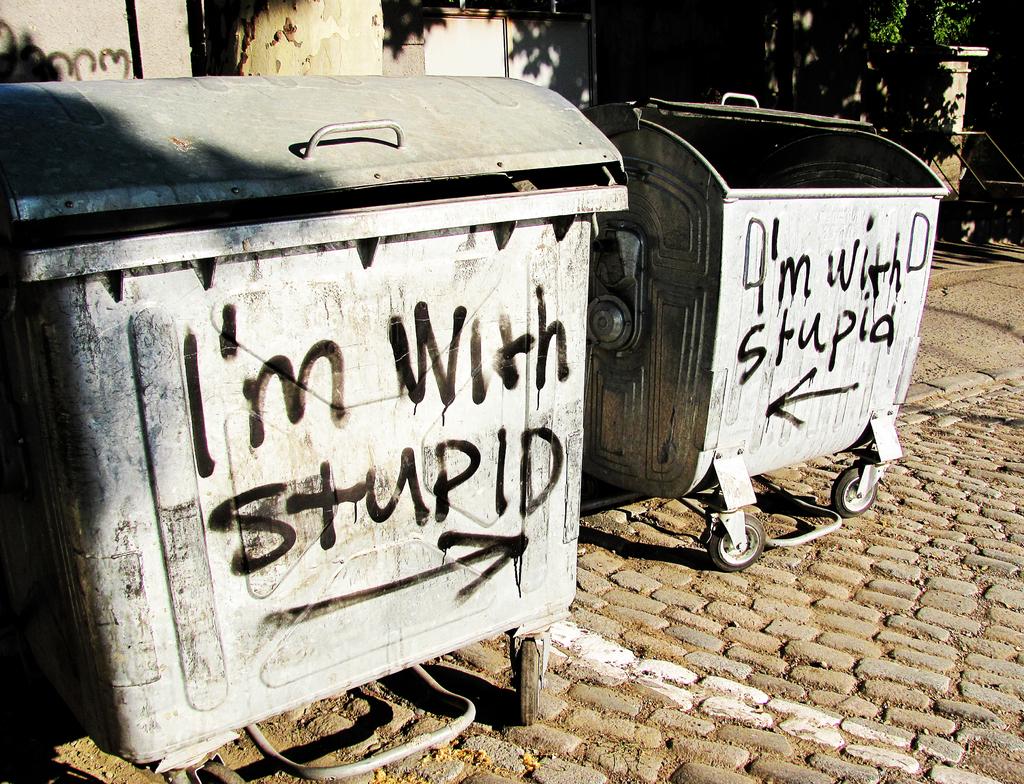What does the bin on the left say?
Ensure brevity in your answer.  I'm with stupid. 